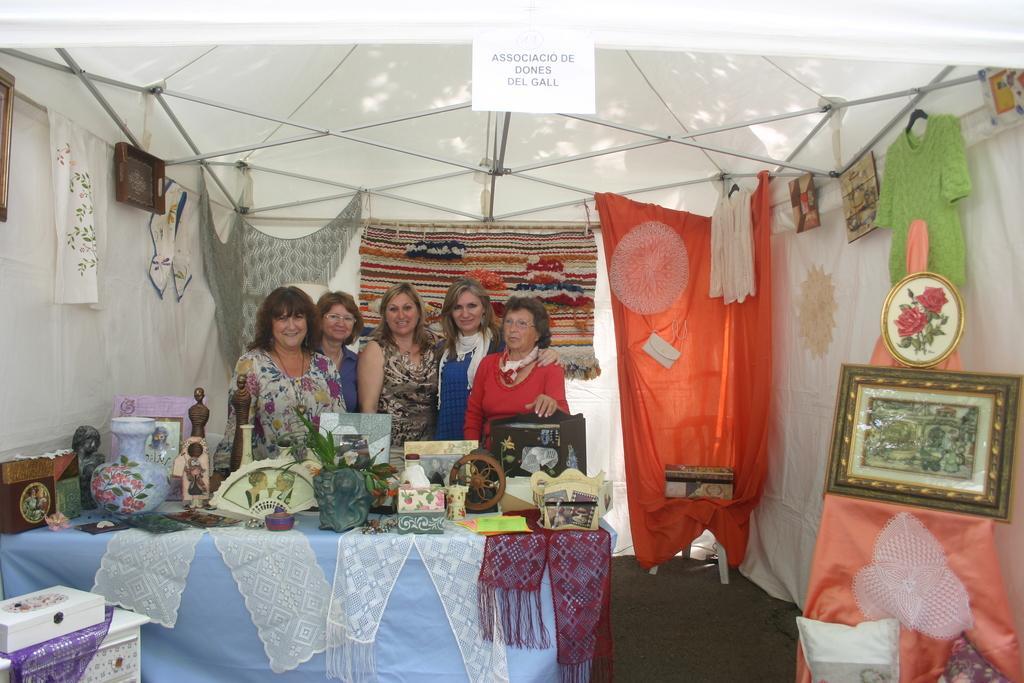How would you summarize this image in a sentence or two? In front of the picture, we see a table on which the flower pots, photo frames and some other objects are placed. Behind that, we see a five women are standing. All of them are smiling and they are posing for the photo. In the left bottom, we see a white table on which a white box is placed. Behind them, we see the clothes in grey, red, white and orange color. On the right side, we see a photo frame and the clothes in pink, green, white and red color. We see the photo frames. At the top, we see a board in white color with some text written on it and we even see a tent in white color. 